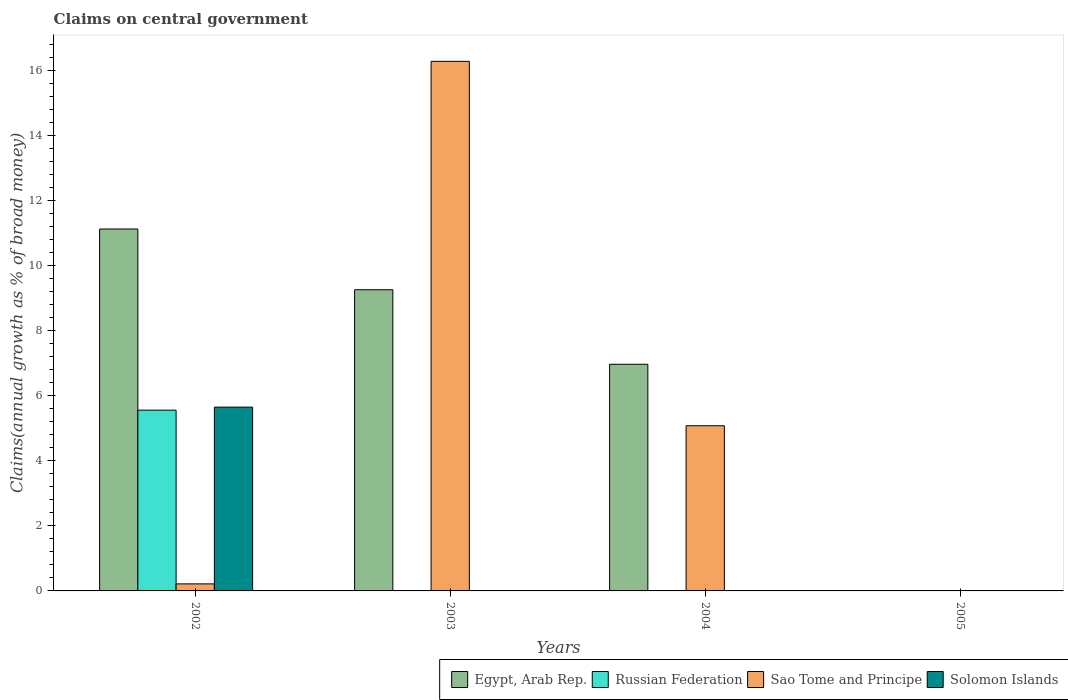Are the number of bars on each tick of the X-axis equal?
Offer a very short reply. No. How many bars are there on the 4th tick from the left?
Provide a short and direct response. 0. What is the label of the 4th group of bars from the left?
Offer a very short reply. 2005. What is the percentage of broad money claimed on centeral government in Egypt, Arab Rep. in 2004?
Offer a terse response. 6.97. Across all years, what is the maximum percentage of broad money claimed on centeral government in Sao Tome and Principe?
Provide a succinct answer. 16.28. Across all years, what is the minimum percentage of broad money claimed on centeral government in Solomon Islands?
Make the answer very short. 0. In which year was the percentage of broad money claimed on centeral government in Russian Federation maximum?
Your answer should be compact. 2002. What is the total percentage of broad money claimed on centeral government in Sao Tome and Principe in the graph?
Ensure brevity in your answer.  21.57. What is the difference between the percentage of broad money claimed on centeral government in Sao Tome and Principe in 2003 and that in 2004?
Provide a short and direct response. 11.2. What is the difference between the percentage of broad money claimed on centeral government in Solomon Islands in 2003 and the percentage of broad money claimed on centeral government in Russian Federation in 2002?
Offer a terse response. -5.56. What is the average percentage of broad money claimed on centeral government in Russian Federation per year?
Your answer should be compact. 1.39. In the year 2002, what is the difference between the percentage of broad money claimed on centeral government in Solomon Islands and percentage of broad money claimed on centeral government in Russian Federation?
Give a very brief answer. 0.09. What is the ratio of the percentage of broad money claimed on centeral government in Sao Tome and Principe in 2003 to that in 2004?
Make the answer very short. 3.21. Is the percentage of broad money claimed on centeral government in Egypt, Arab Rep. in 2002 less than that in 2003?
Offer a very short reply. No. What is the difference between the highest and the second highest percentage of broad money claimed on centeral government in Sao Tome and Principe?
Provide a short and direct response. 11.2. What is the difference between the highest and the lowest percentage of broad money claimed on centeral government in Solomon Islands?
Your response must be concise. 5.65. In how many years, is the percentage of broad money claimed on centeral government in Sao Tome and Principe greater than the average percentage of broad money claimed on centeral government in Sao Tome and Principe taken over all years?
Your response must be concise. 1. Is it the case that in every year, the sum of the percentage of broad money claimed on centeral government in Russian Federation and percentage of broad money claimed on centeral government in Egypt, Arab Rep. is greater than the sum of percentage of broad money claimed on centeral government in Sao Tome and Principe and percentage of broad money claimed on centeral government in Solomon Islands?
Ensure brevity in your answer.  No. Does the graph contain any zero values?
Provide a short and direct response. Yes. Does the graph contain grids?
Give a very brief answer. No. How many legend labels are there?
Offer a terse response. 4. How are the legend labels stacked?
Ensure brevity in your answer.  Horizontal. What is the title of the graph?
Make the answer very short. Claims on central government. Does "Canada" appear as one of the legend labels in the graph?
Make the answer very short. No. What is the label or title of the X-axis?
Your response must be concise. Years. What is the label or title of the Y-axis?
Your answer should be compact. Claims(annual growth as % of broad money). What is the Claims(annual growth as % of broad money) of Egypt, Arab Rep. in 2002?
Your answer should be very brief. 11.13. What is the Claims(annual growth as % of broad money) of Russian Federation in 2002?
Offer a very short reply. 5.56. What is the Claims(annual growth as % of broad money) in Sao Tome and Principe in 2002?
Your response must be concise. 0.22. What is the Claims(annual growth as % of broad money) of Solomon Islands in 2002?
Make the answer very short. 5.65. What is the Claims(annual growth as % of broad money) in Egypt, Arab Rep. in 2003?
Ensure brevity in your answer.  9.26. What is the Claims(annual growth as % of broad money) in Russian Federation in 2003?
Your response must be concise. 0. What is the Claims(annual growth as % of broad money) of Sao Tome and Principe in 2003?
Offer a terse response. 16.28. What is the Claims(annual growth as % of broad money) of Egypt, Arab Rep. in 2004?
Provide a short and direct response. 6.97. What is the Claims(annual growth as % of broad money) in Russian Federation in 2004?
Your answer should be compact. 0. What is the Claims(annual growth as % of broad money) of Sao Tome and Principe in 2004?
Give a very brief answer. 5.08. What is the Claims(annual growth as % of broad money) in Solomon Islands in 2004?
Keep it short and to the point. 0. What is the Claims(annual growth as % of broad money) in Russian Federation in 2005?
Your response must be concise. 0. What is the Claims(annual growth as % of broad money) in Sao Tome and Principe in 2005?
Offer a very short reply. 0. Across all years, what is the maximum Claims(annual growth as % of broad money) of Egypt, Arab Rep.?
Keep it short and to the point. 11.13. Across all years, what is the maximum Claims(annual growth as % of broad money) in Russian Federation?
Make the answer very short. 5.56. Across all years, what is the maximum Claims(annual growth as % of broad money) of Sao Tome and Principe?
Keep it short and to the point. 16.28. Across all years, what is the maximum Claims(annual growth as % of broad money) in Solomon Islands?
Offer a terse response. 5.65. What is the total Claims(annual growth as % of broad money) in Egypt, Arab Rep. in the graph?
Your answer should be compact. 27.35. What is the total Claims(annual growth as % of broad money) of Russian Federation in the graph?
Keep it short and to the point. 5.56. What is the total Claims(annual growth as % of broad money) in Sao Tome and Principe in the graph?
Keep it short and to the point. 21.57. What is the total Claims(annual growth as % of broad money) in Solomon Islands in the graph?
Your response must be concise. 5.65. What is the difference between the Claims(annual growth as % of broad money) in Egypt, Arab Rep. in 2002 and that in 2003?
Your answer should be very brief. 1.87. What is the difference between the Claims(annual growth as % of broad money) in Sao Tome and Principe in 2002 and that in 2003?
Give a very brief answer. -16.06. What is the difference between the Claims(annual growth as % of broad money) in Egypt, Arab Rep. in 2002 and that in 2004?
Make the answer very short. 4.16. What is the difference between the Claims(annual growth as % of broad money) in Sao Tome and Principe in 2002 and that in 2004?
Keep it short and to the point. -4.86. What is the difference between the Claims(annual growth as % of broad money) of Egypt, Arab Rep. in 2003 and that in 2004?
Offer a terse response. 2.29. What is the difference between the Claims(annual growth as % of broad money) in Sao Tome and Principe in 2003 and that in 2004?
Offer a terse response. 11.2. What is the difference between the Claims(annual growth as % of broad money) of Egypt, Arab Rep. in 2002 and the Claims(annual growth as % of broad money) of Sao Tome and Principe in 2003?
Offer a very short reply. -5.15. What is the difference between the Claims(annual growth as % of broad money) in Russian Federation in 2002 and the Claims(annual growth as % of broad money) in Sao Tome and Principe in 2003?
Your answer should be compact. -10.72. What is the difference between the Claims(annual growth as % of broad money) of Egypt, Arab Rep. in 2002 and the Claims(annual growth as % of broad money) of Sao Tome and Principe in 2004?
Offer a very short reply. 6.05. What is the difference between the Claims(annual growth as % of broad money) of Russian Federation in 2002 and the Claims(annual growth as % of broad money) of Sao Tome and Principe in 2004?
Keep it short and to the point. 0.48. What is the difference between the Claims(annual growth as % of broad money) of Egypt, Arab Rep. in 2003 and the Claims(annual growth as % of broad money) of Sao Tome and Principe in 2004?
Offer a terse response. 4.18. What is the average Claims(annual growth as % of broad money) in Egypt, Arab Rep. per year?
Provide a short and direct response. 6.84. What is the average Claims(annual growth as % of broad money) in Russian Federation per year?
Provide a short and direct response. 1.39. What is the average Claims(annual growth as % of broad money) in Sao Tome and Principe per year?
Offer a very short reply. 5.39. What is the average Claims(annual growth as % of broad money) in Solomon Islands per year?
Keep it short and to the point. 1.41. In the year 2002, what is the difference between the Claims(annual growth as % of broad money) of Egypt, Arab Rep. and Claims(annual growth as % of broad money) of Russian Federation?
Ensure brevity in your answer.  5.57. In the year 2002, what is the difference between the Claims(annual growth as % of broad money) of Egypt, Arab Rep. and Claims(annual growth as % of broad money) of Sao Tome and Principe?
Offer a terse response. 10.91. In the year 2002, what is the difference between the Claims(annual growth as % of broad money) in Egypt, Arab Rep. and Claims(annual growth as % of broad money) in Solomon Islands?
Your response must be concise. 5.48. In the year 2002, what is the difference between the Claims(annual growth as % of broad money) of Russian Federation and Claims(annual growth as % of broad money) of Sao Tome and Principe?
Your response must be concise. 5.34. In the year 2002, what is the difference between the Claims(annual growth as % of broad money) in Russian Federation and Claims(annual growth as % of broad money) in Solomon Islands?
Offer a very short reply. -0.09. In the year 2002, what is the difference between the Claims(annual growth as % of broad money) of Sao Tome and Principe and Claims(annual growth as % of broad money) of Solomon Islands?
Make the answer very short. -5.43. In the year 2003, what is the difference between the Claims(annual growth as % of broad money) of Egypt, Arab Rep. and Claims(annual growth as % of broad money) of Sao Tome and Principe?
Offer a very short reply. -7.02. In the year 2004, what is the difference between the Claims(annual growth as % of broad money) in Egypt, Arab Rep. and Claims(annual growth as % of broad money) in Sao Tome and Principe?
Keep it short and to the point. 1.89. What is the ratio of the Claims(annual growth as % of broad money) of Egypt, Arab Rep. in 2002 to that in 2003?
Offer a terse response. 1.2. What is the ratio of the Claims(annual growth as % of broad money) in Sao Tome and Principe in 2002 to that in 2003?
Ensure brevity in your answer.  0.01. What is the ratio of the Claims(annual growth as % of broad money) of Egypt, Arab Rep. in 2002 to that in 2004?
Give a very brief answer. 1.6. What is the ratio of the Claims(annual growth as % of broad money) of Sao Tome and Principe in 2002 to that in 2004?
Make the answer very short. 0.04. What is the ratio of the Claims(annual growth as % of broad money) of Egypt, Arab Rep. in 2003 to that in 2004?
Your answer should be very brief. 1.33. What is the ratio of the Claims(annual growth as % of broad money) of Sao Tome and Principe in 2003 to that in 2004?
Your response must be concise. 3.21. What is the difference between the highest and the second highest Claims(annual growth as % of broad money) of Egypt, Arab Rep.?
Make the answer very short. 1.87. What is the difference between the highest and the second highest Claims(annual growth as % of broad money) of Sao Tome and Principe?
Provide a succinct answer. 11.2. What is the difference between the highest and the lowest Claims(annual growth as % of broad money) of Egypt, Arab Rep.?
Keep it short and to the point. 11.13. What is the difference between the highest and the lowest Claims(annual growth as % of broad money) of Russian Federation?
Your answer should be compact. 5.56. What is the difference between the highest and the lowest Claims(annual growth as % of broad money) of Sao Tome and Principe?
Offer a very short reply. 16.28. What is the difference between the highest and the lowest Claims(annual growth as % of broad money) of Solomon Islands?
Provide a succinct answer. 5.65. 